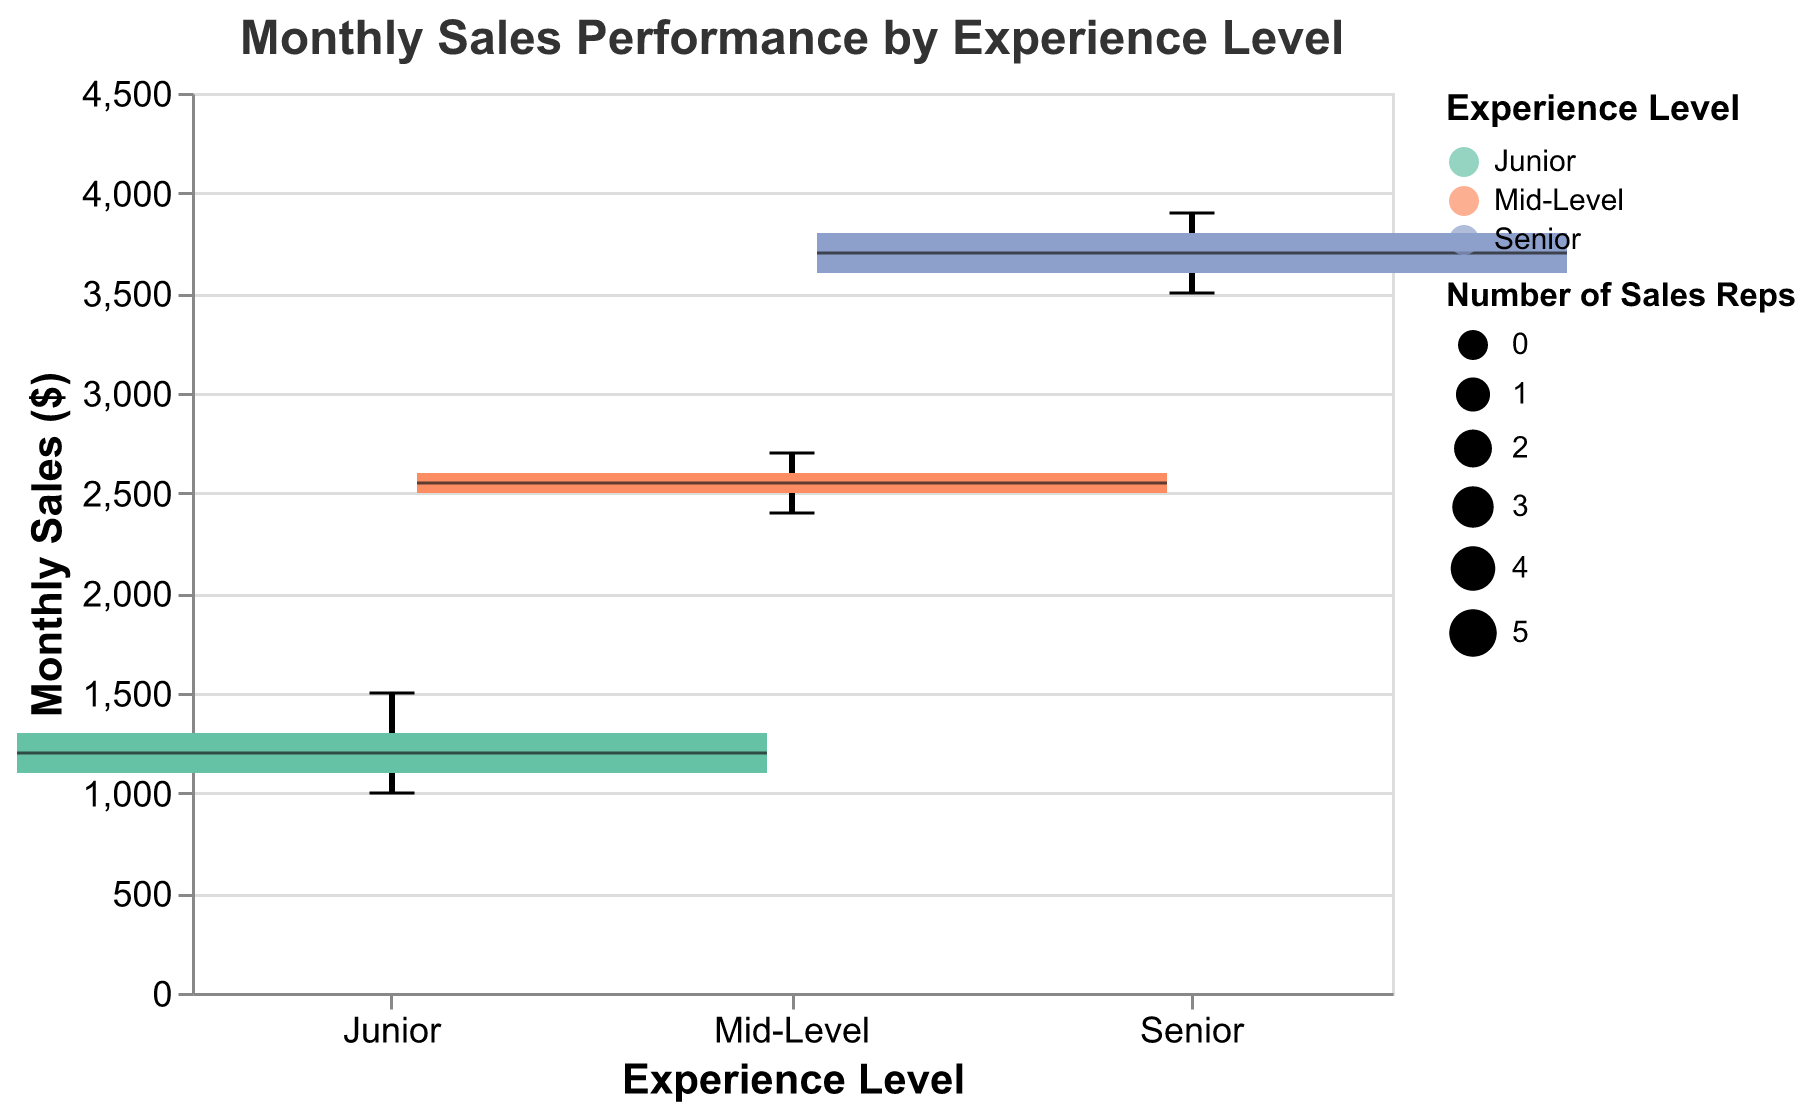What is the median monthly sales for Mid-Level sales representatives? Identify the median point visually in the box plot for the Mid-Level group. The median sales for Mid-Level representatives is $2550 due to the center line within the box.
Answer: $2550 How many sales representatives are there in each experience level group? Observe the width of each boxplot; wider boxes represent more data points. The widths indicate 5 sales representatives for Junior, 5 for Mid-Level, and 5 for Senior.
Answer: 5 for each group Which experience level has the highest monthly sales median? Compare the median lines (center lines in each box) for all experience levels. The Senior group has the highest median at $3700.
Answer: Senior What is the range of monthly sales for Junior sales representatives? Identify the minimum and maximum values from the whiskers of the Junior boxplot. The range for Junior is from $1000 to $1500, which is a difference of $500.
Answer: $500 Which experience group has the largest spread in monthly sales? Compare the lengths of the whiskers for each group. The Senior group has the largest spread with data ranging from $3500 to $3900, which amounts to a spread of $400.
Answer: Senior What is the difference between the median monthly sales of Junior and Senior sales representatives? Subtract the median of Junior ($1200) from that of Senior ($3700). The difference is $3700 - $1200 = $2500.
Answer: $2500 How does the performance of the top salesperson in the Junior category compare to the top salesperson in the Senior category? Find the maximum values in the Junior and Senior boxplots; the top salesperson in the Junior category has $1500, while in the Senior category the top salesperson has $3900.
Answer: $1500 for Junior, $3900 for Senior Are there any overlapping ranges of monthly sales between groups? Check if the whisker ranges intersect. The Monthly Sales of Mid-Level (2400-2700) and Senior (3500-3900) do not overlap. However, Mid-Level and Junior do not overlap either.
Answer: No overlap Which group has the smallest variation in their monthly sales? Compare the lengths of the interquartile ranges (IQR) of each box. The Junior group has the smallest IQR from $1100 to $1300, which is a range of $200.
Answer: Junior What proportion of the data points fall within the interquartile range for Senior sales representatives? The IQR in boxplots contains 50% of the data points (from the 25th to the 75th percentile). For the Senior group, the IQR is between $3600 and $3800.
Answer: 50% 